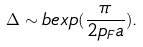<formula> <loc_0><loc_0><loc_500><loc_500>\Delta \sim b e x p ( \frac { \pi } { 2 p _ { F } a } ) .</formula> 